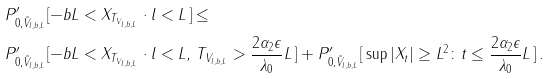Convert formula to latex. <formula><loc_0><loc_0><loc_500><loc_500>& P ^ { \prime } _ { 0 , \tilde { V } _ { l , b , L } } [ - b L < X _ { T _ { V _ { l , b , L } } } \cdot l < L \, ] \leq \\ & P ^ { \prime } _ { 0 , \tilde { V } _ { l , b , L } } [ - b L < X _ { T _ { V _ { l , b , L } } } \cdot l < L , \, T _ { V _ { l , b , L } } > \frac { 2 \alpha _ { 2 } \epsilon } { \lambda _ { 0 } } L \, ] + P ^ { \prime } _ { 0 , \tilde { V } _ { l , b , L } } [ \, \sup | X _ { t } | \geq L ^ { 2 } \colon t \leq \frac { 2 \alpha _ { 2 } \epsilon } { \lambda _ { 0 } } L \, ] \, .</formula> 